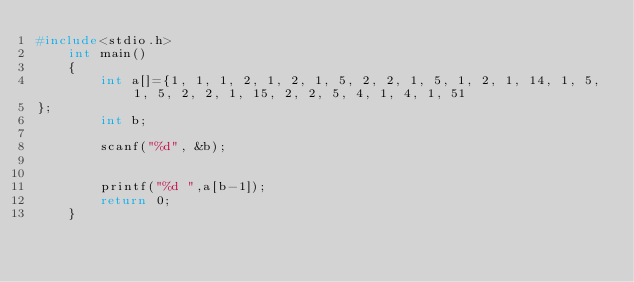Convert code to text. <code><loc_0><loc_0><loc_500><loc_500><_C_>#include<stdio.h>
    int main()
    {
        int a[]={1, 1, 1, 2, 1, 2, 1, 5, 2, 2, 1, 5, 1, 2, 1, 14, 1, 5, 1, 5, 2, 2, 1, 15, 2, 2, 5, 4, 1, 4, 1, 51
};
        int b;
        
        scanf("%d", &b);
        
        
        printf("%d ",a[b-1]);
        return 0;
    }</code> 